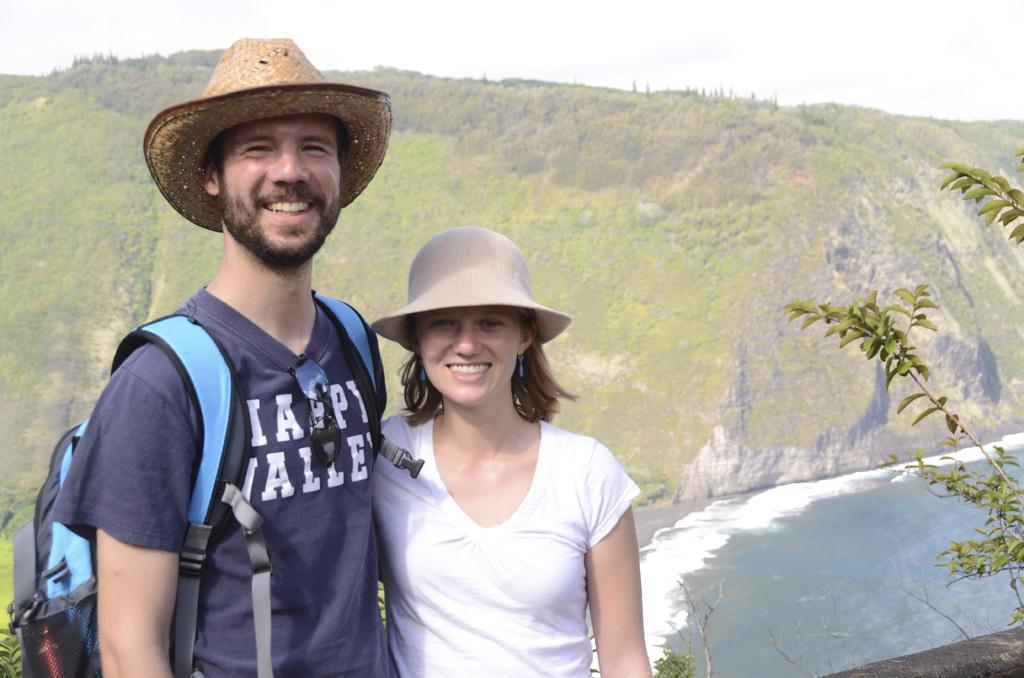Provide a one-sentence caption for the provided image. His shirt with white writing the bottom word says valley. 